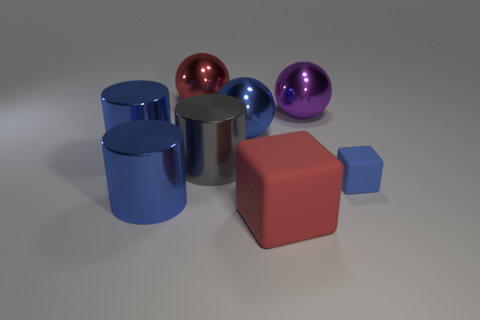Is there anything else that has the same size as the blue matte block?
Give a very brief answer. No. Are there fewer big spheres that are behind the big red ball than purple metal spheres?
Your answer should be very brief. Yes. How many big metallic objects have the same color as the tiny cube?
Offer a very short reply. 3. Is the number of big metal cylinders less than the number of gray metallic balls?
Offer a terse response. No. Do the tiny object and the red sphere have the same material?
Give a very brief answer. No. What number of other things are there of the same size as the blue matte cube?
Offer a very short reply. 0. What is the color of the cylinder to the right of the blue shiny cylinder that is in front of the large gray cylinder?
Provide a short and direct response. Gray. What number of other objects are the same shape as the gray thing?
Offer a terse response. 2. Are there any purple spheres made of the same material as the big gray object?
Give a very brief answer. Yes. There is a red thing that is the same size as the red sphere; what is it made of?
Provide a short and direct response. Rubber. 